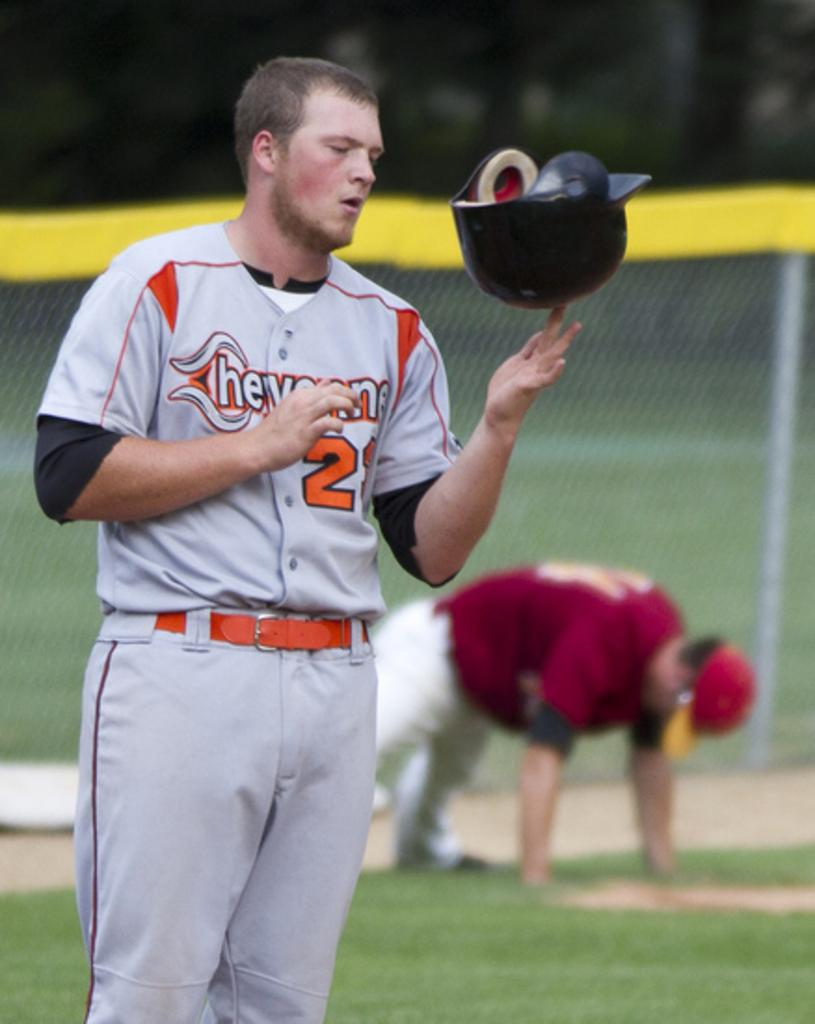<image>
Describe the image concisely. Player number 2 is spinning his batting helmet on one finger. 